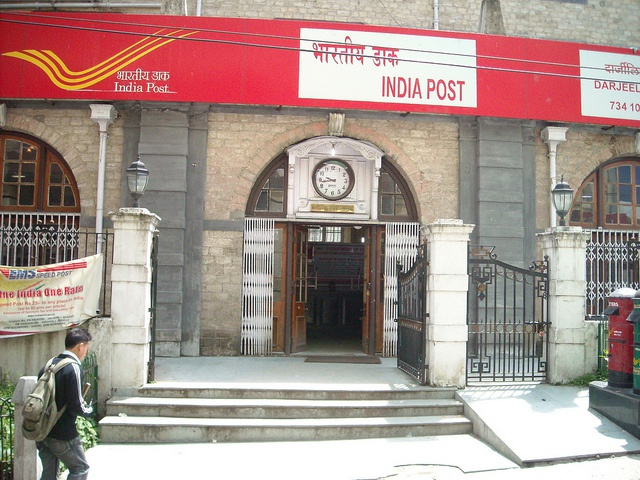Describe the objects in this image and their specific colors. I can see people in darkgreen, black, gray, darkgray, and white tones, backpack in darkgreen, gray, darkgray, and black tones, and clock in darkgreen, lightgray, gray, and darkgray tones in this image. 